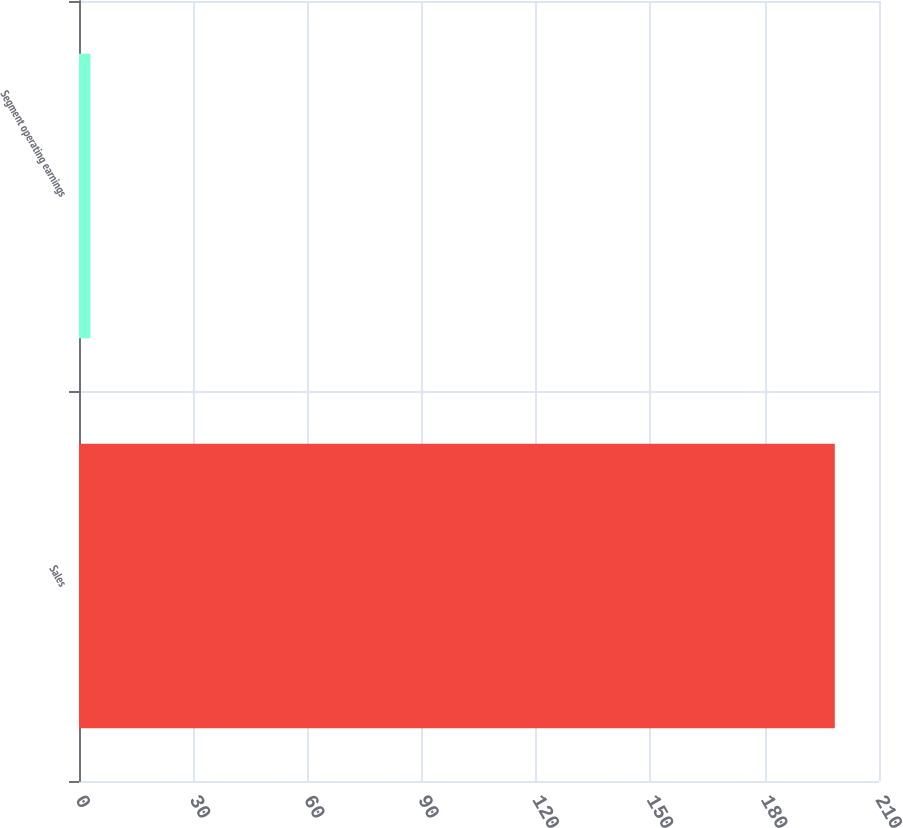Convert chart to OTSL. <chart><loc_0><loc_0><loc_500><loc_500><bar_chart><fcel>Sales<fcel>Segment operating earnings<nl><fcel>198.4<fcel>3<nl></chart> 